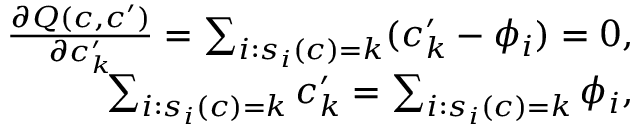<formula> <loc_0><loc_0><loc_500><loc_500>\begin{array} { r } { \frac { \partial Q ( c , c ^ { \prime } ) } { \partial c _ { k } ^ { \prime } } = \sum _ { i \colon s _ { i } ( c ) = k } ( c _ { k } ^ { \prime } - \phi _ { i } ) = 0 , } \\ { \sum _ { i \colon s _ { i } ( c ) = k } c _ { k } ^ { \prime } = \sum _ { i \colon s _ { i } ( c ) = k } \phi _ { i } , } \end{array}</formula> 